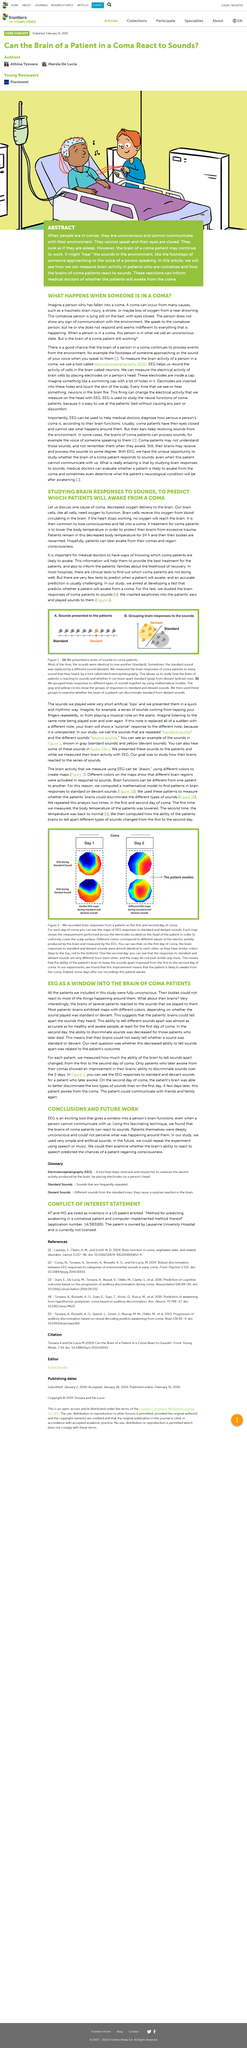Point out several critical features in this image. The patient woke up several days after their recordings were conducted. The diagonal line in Figure 1 represents the distribution of responses to standard and deviant sounds for individuals in the sample. Coma patients are typically placed in a reduced body temperature state for 24 hours as a standard medical procedure. Electroencephalography, commonly referred to as EEG, is a diagnostic tool that measures and records the electrical activity of the brain. An EEG is a medical device used to measure the brain activity of a person, particularly in cases where the person is in a coma. 